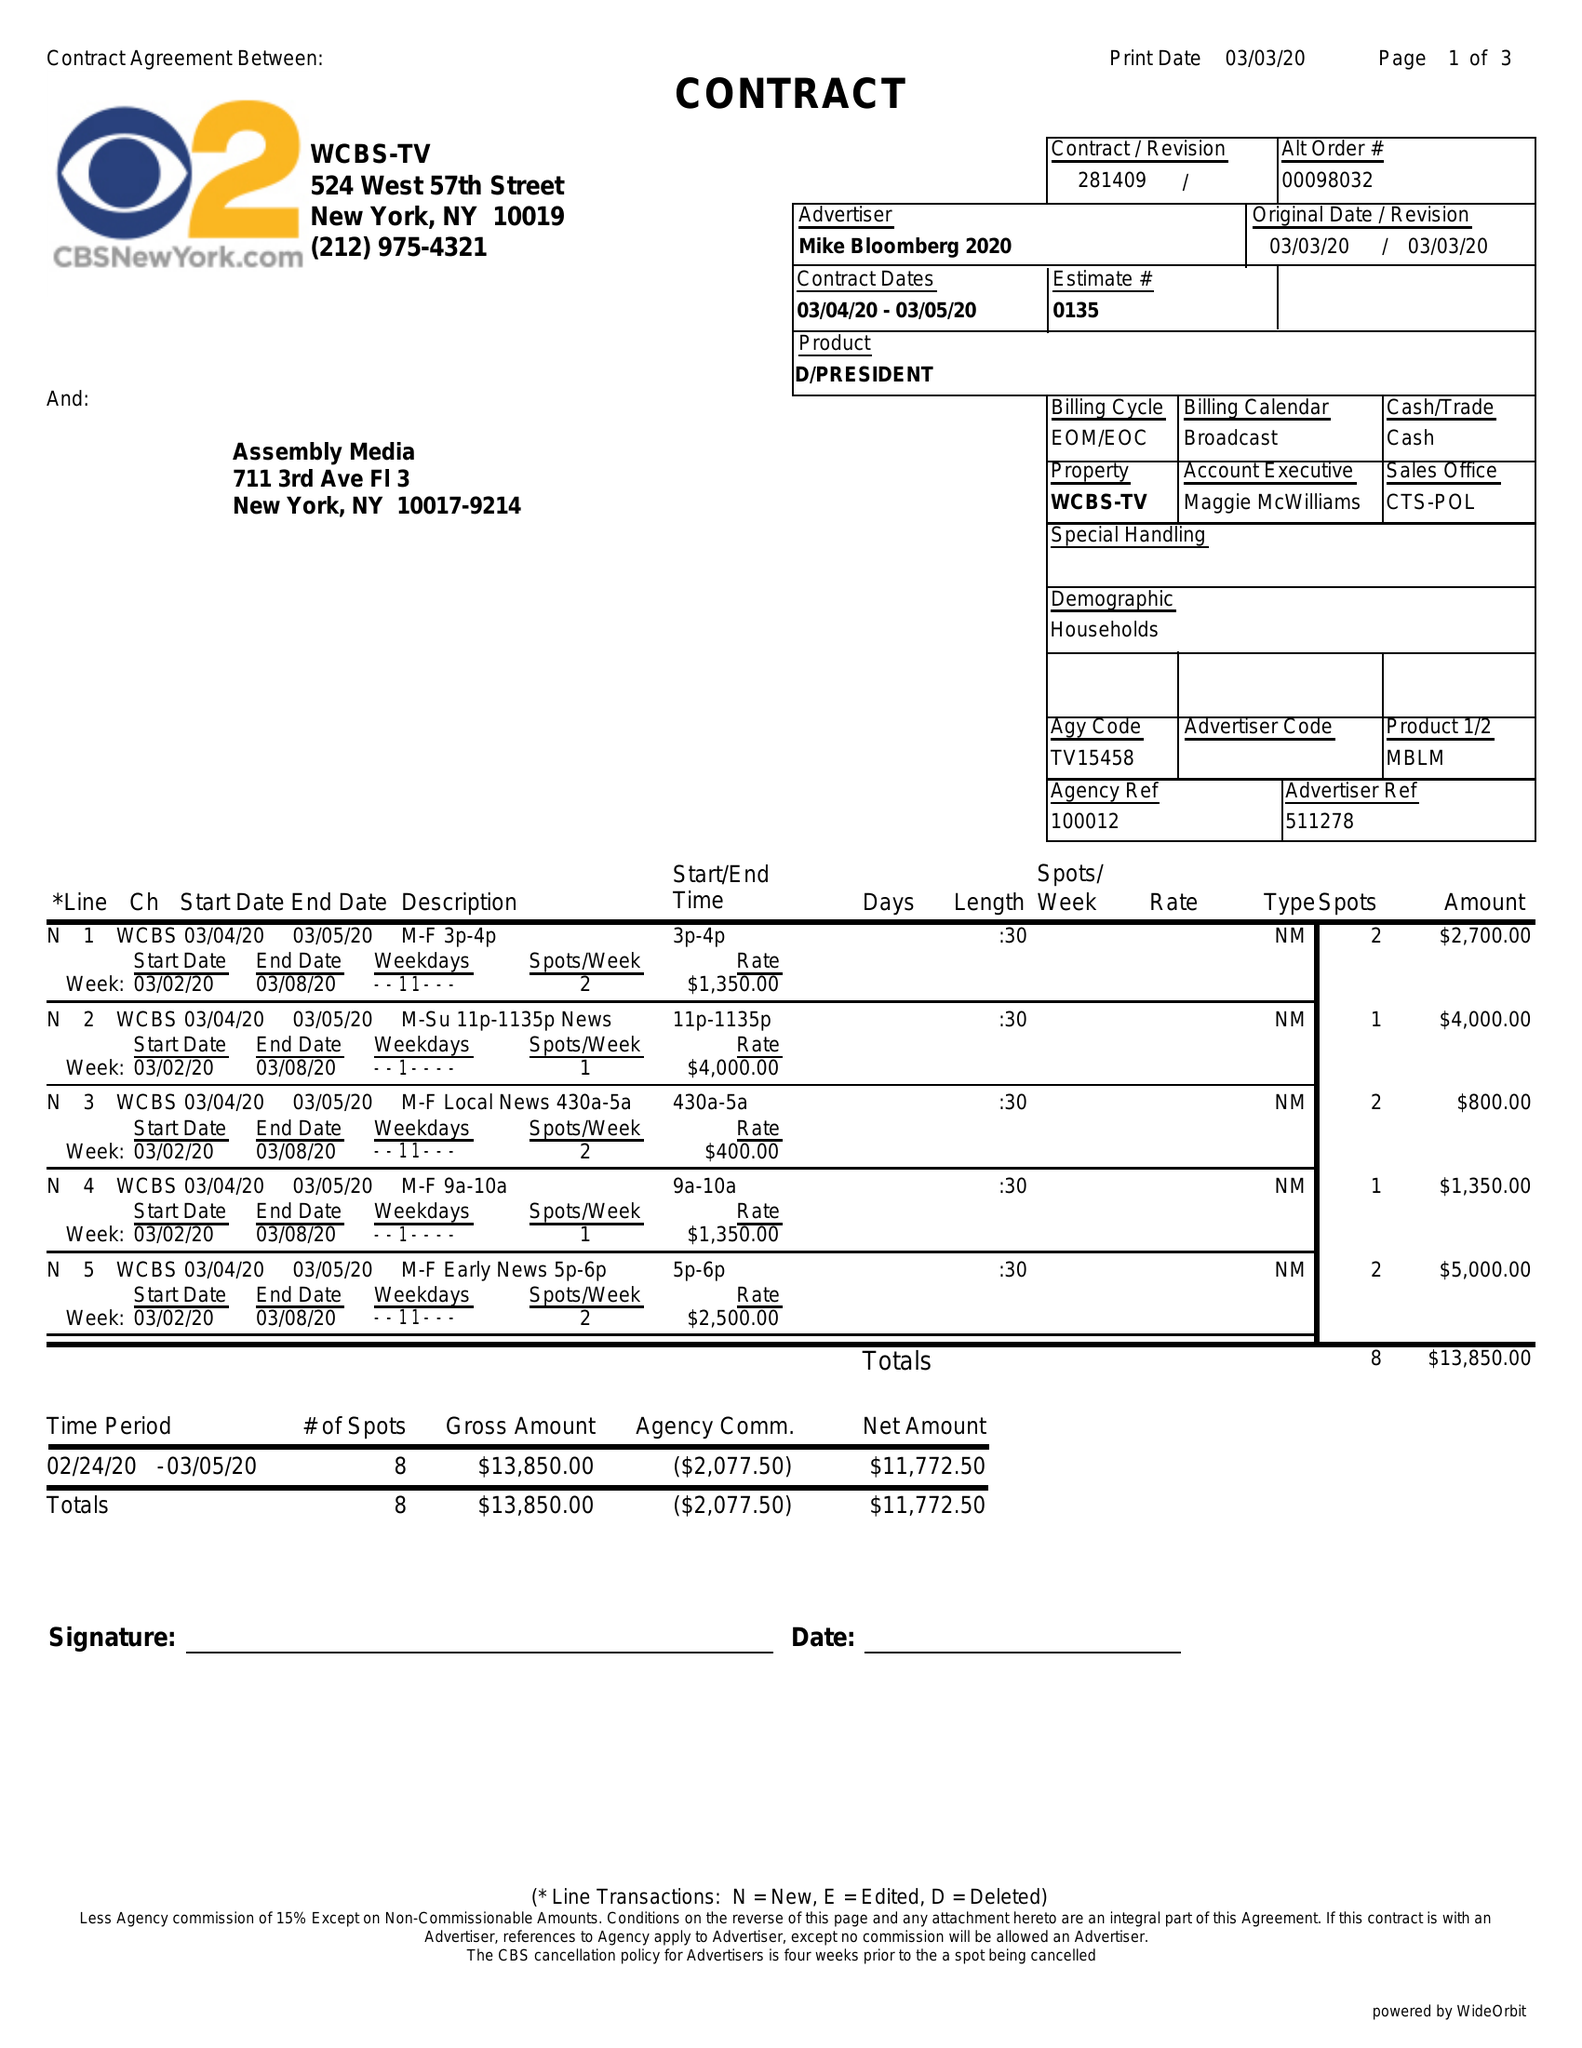What is the value for the flight_to?
Answer the question using a single word or phrase. 03/05/20 